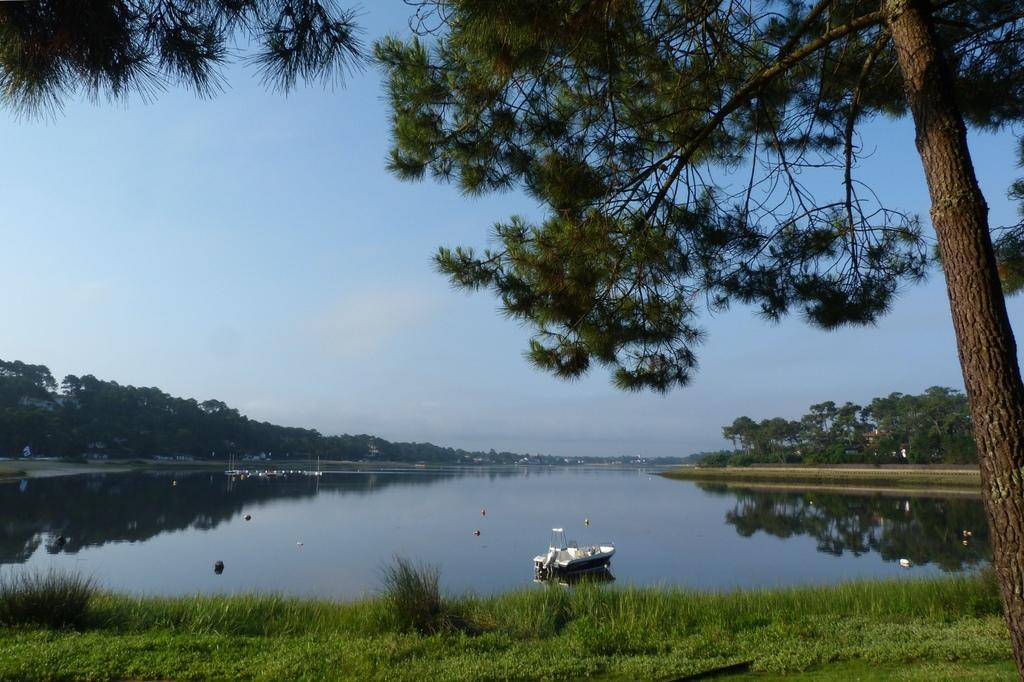What is the main subject in the center of the image? There is a boat in the center of the image. What type of environment is depicted in the image? There is water visible in the image, suggesting a water-based environment. What type of vegetation is present at the bottom of the image? There is grass at the bottom of the image. What can be seen in the background of the image? There are many trees in the background of the image. How many passengers are resting on the boat's system in the image? There is no information about passengers or a system on the boat in the image. 